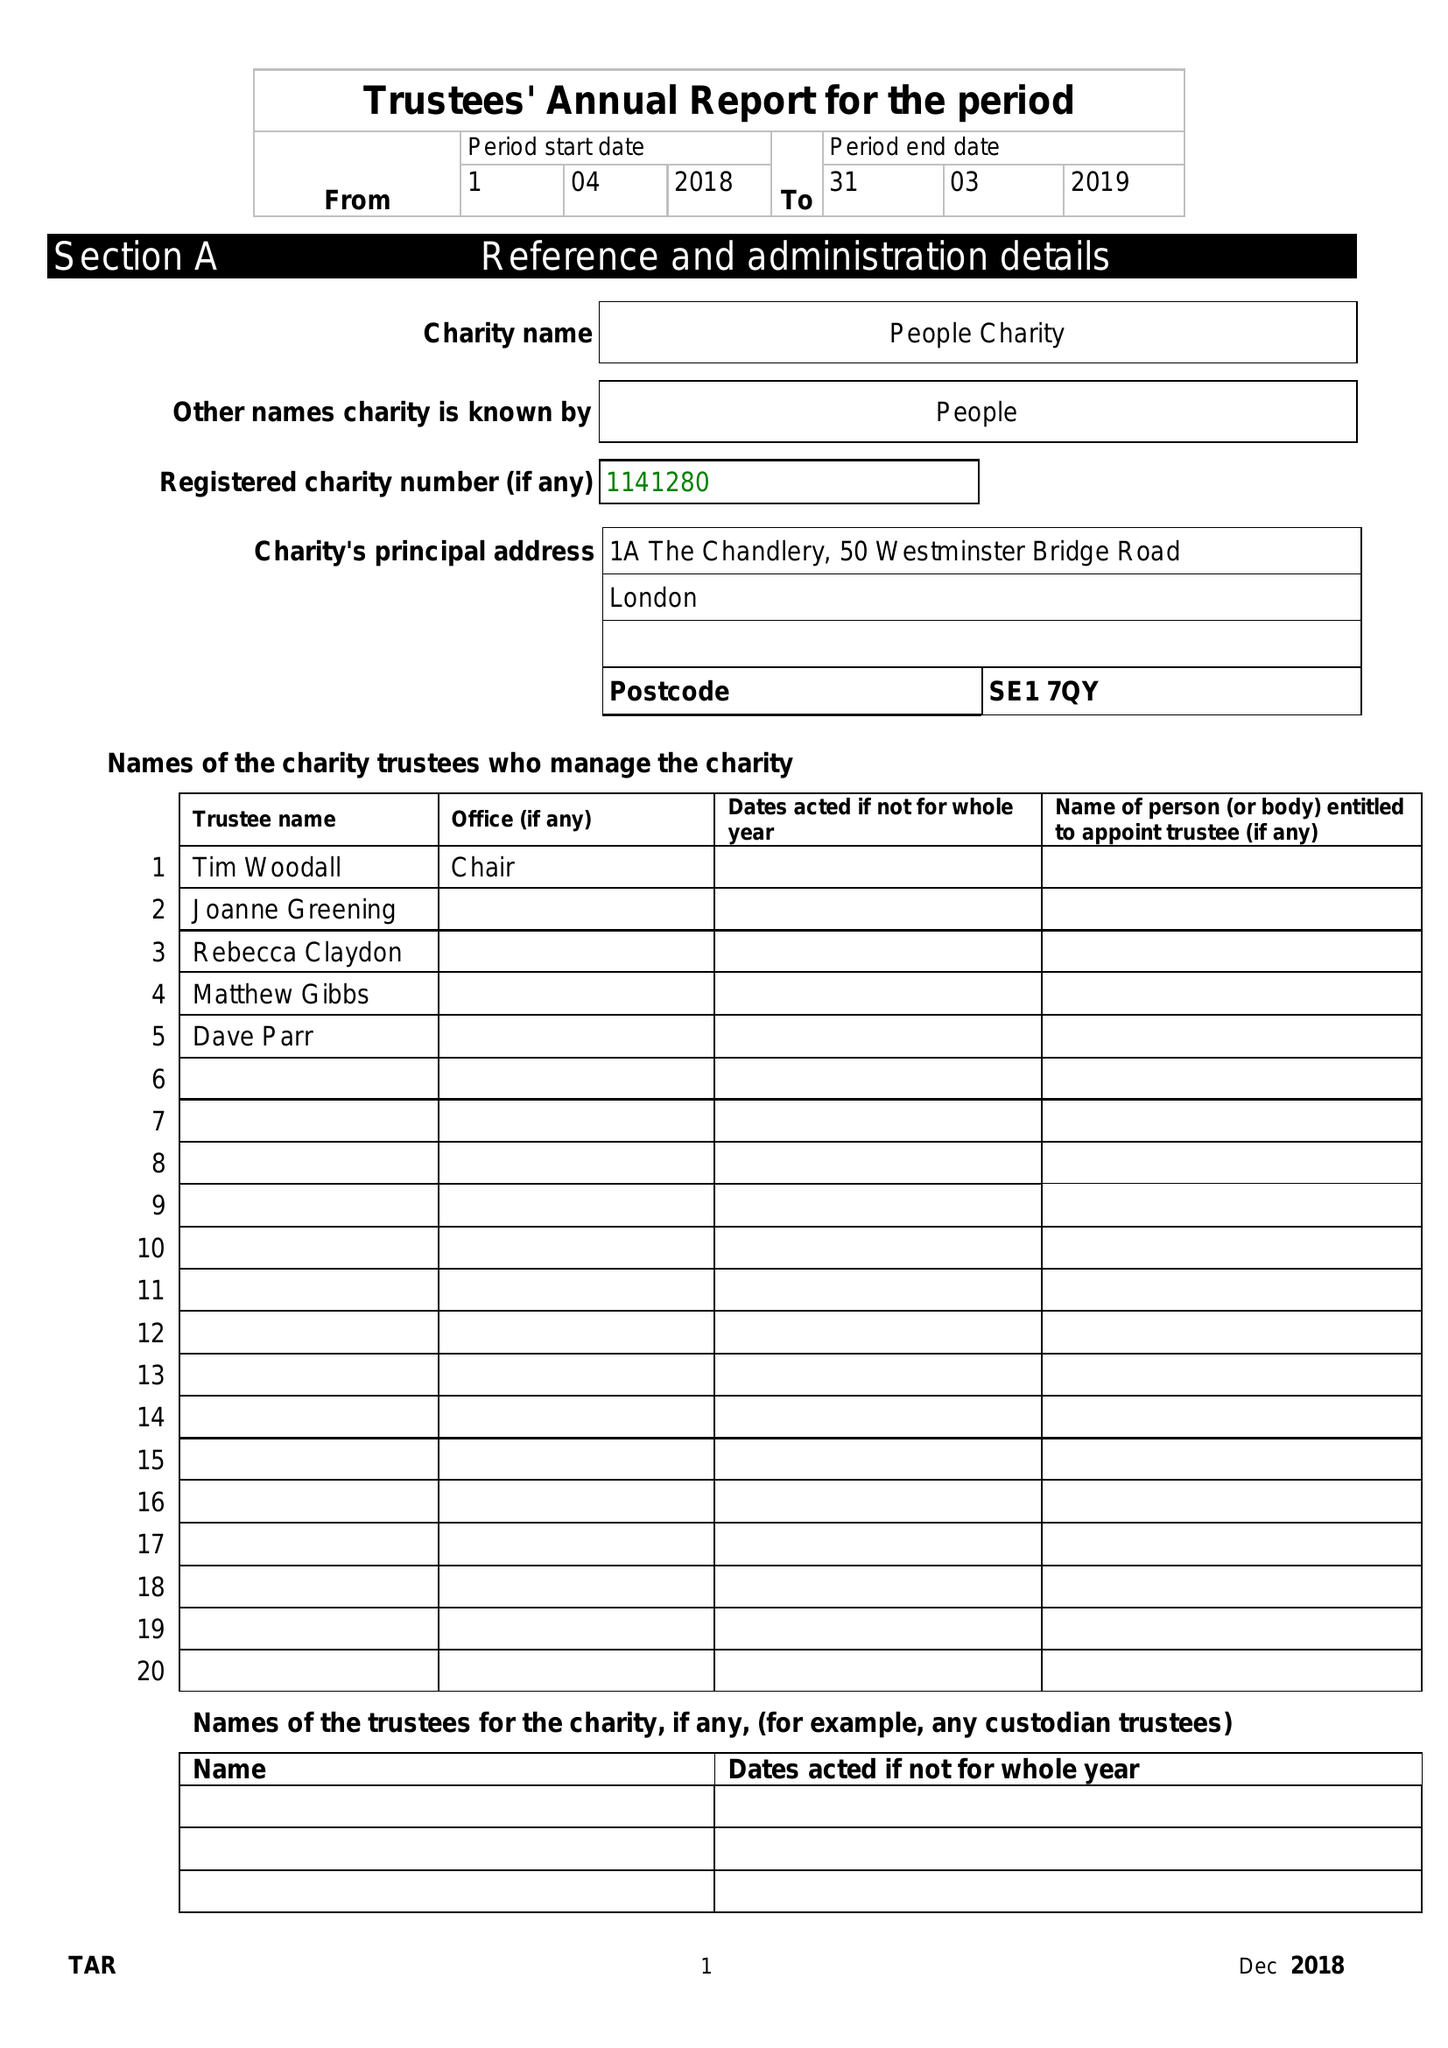What is the value for the address__post_town?
Answer the question using a single word or phrase. LONDON 